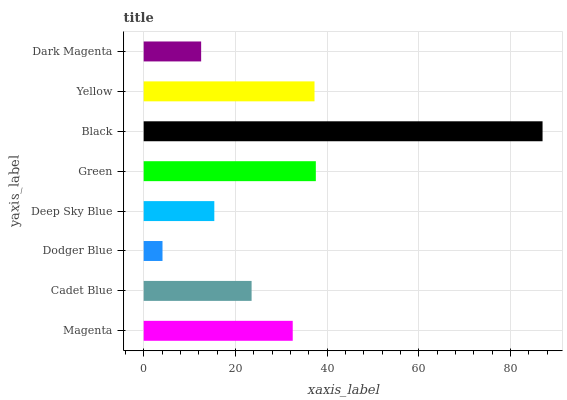Is Dodger Blue the minimum?
Answer yes or no. Yes. Is Black the maximum?
Answer yes or no. Yes. Is Cadet Blue the minimum?
Answer yes or no. No. Is Cadet Blue the maximum?
Answer yes or no. No. Is Magenta greater than Cadet Blue?
Answer yes or no. Yes. Is Cadet Blue less than Magenta?
Answer yes or no. Yes. Is Cadet Blue greater than Magenta?
Answer yes or no. No. Is Magenta less than Cadet Blue?
Answer yes or no. No. Is Magenta the high median?
Answer yes or no. Yes. Is Cadet Blue the low median?
Answer yes or no. Yes. Is Dodger Blue the high median?
Answer yes or no. No. Is Dark Magenta the low median?
Answer yes or no. No. 